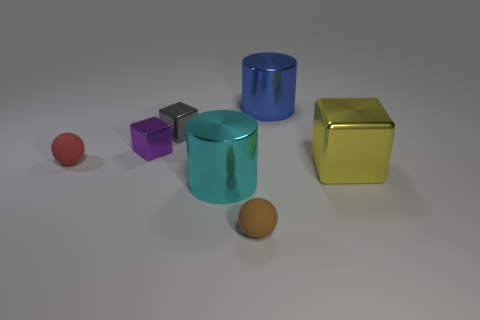Subtract all small cubes. How many cubes are left? 1 Add 2 purple metal things. How many objects exist? 9 Subtract all yellow blocks. How many blocks are left? 2 Add 7 tiny brown matte objects. How many tiny brown matte objects are left? 8 Add 5 tiny objects. How many tiny objects exist? 9 Subtract 0 purple spheres. How many objects are left? 7 Subtract all blocks. How many objects are left? 4 Subtract all green cubes. Subtract all red spheres. How many cubes are left? 3 Subtract all small objects. Subtract all cyan things. How many objects are left? 2 